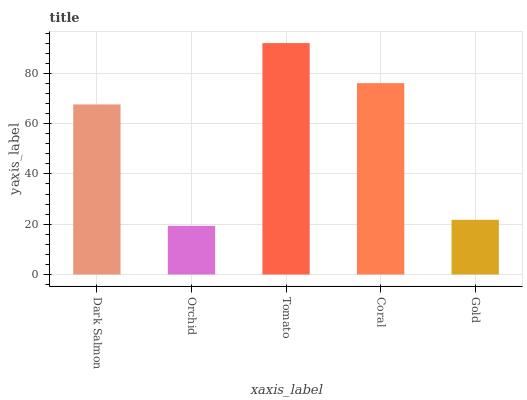Is Orchid the minimum?
Answer yes or no. Yes. Is Tomato the maximum?
Answer yes or no. Yes. Is Tomato the minimum?
Answer yes or no. No. Is Orchid the maximum?
Answer yes or no. No. Is Tomato greater than Orchid?
Answer yes or no. Yes. Is Orchid less than Tomato?
Answer yes or no. Yes. Is Orchid greater than Tomato?
Answer yes or no. No. Is Tomato less than Orchid?
Answer yes or no. No. Is Dark Salmon the high median?
Answer yes or no. Yes. Is Dark Salmon the low median?
Answer yes or no. Yes. Is Tomato the high median?
Answer yes or no. No. Is Coral the low median?
Answer yes or no. No. 